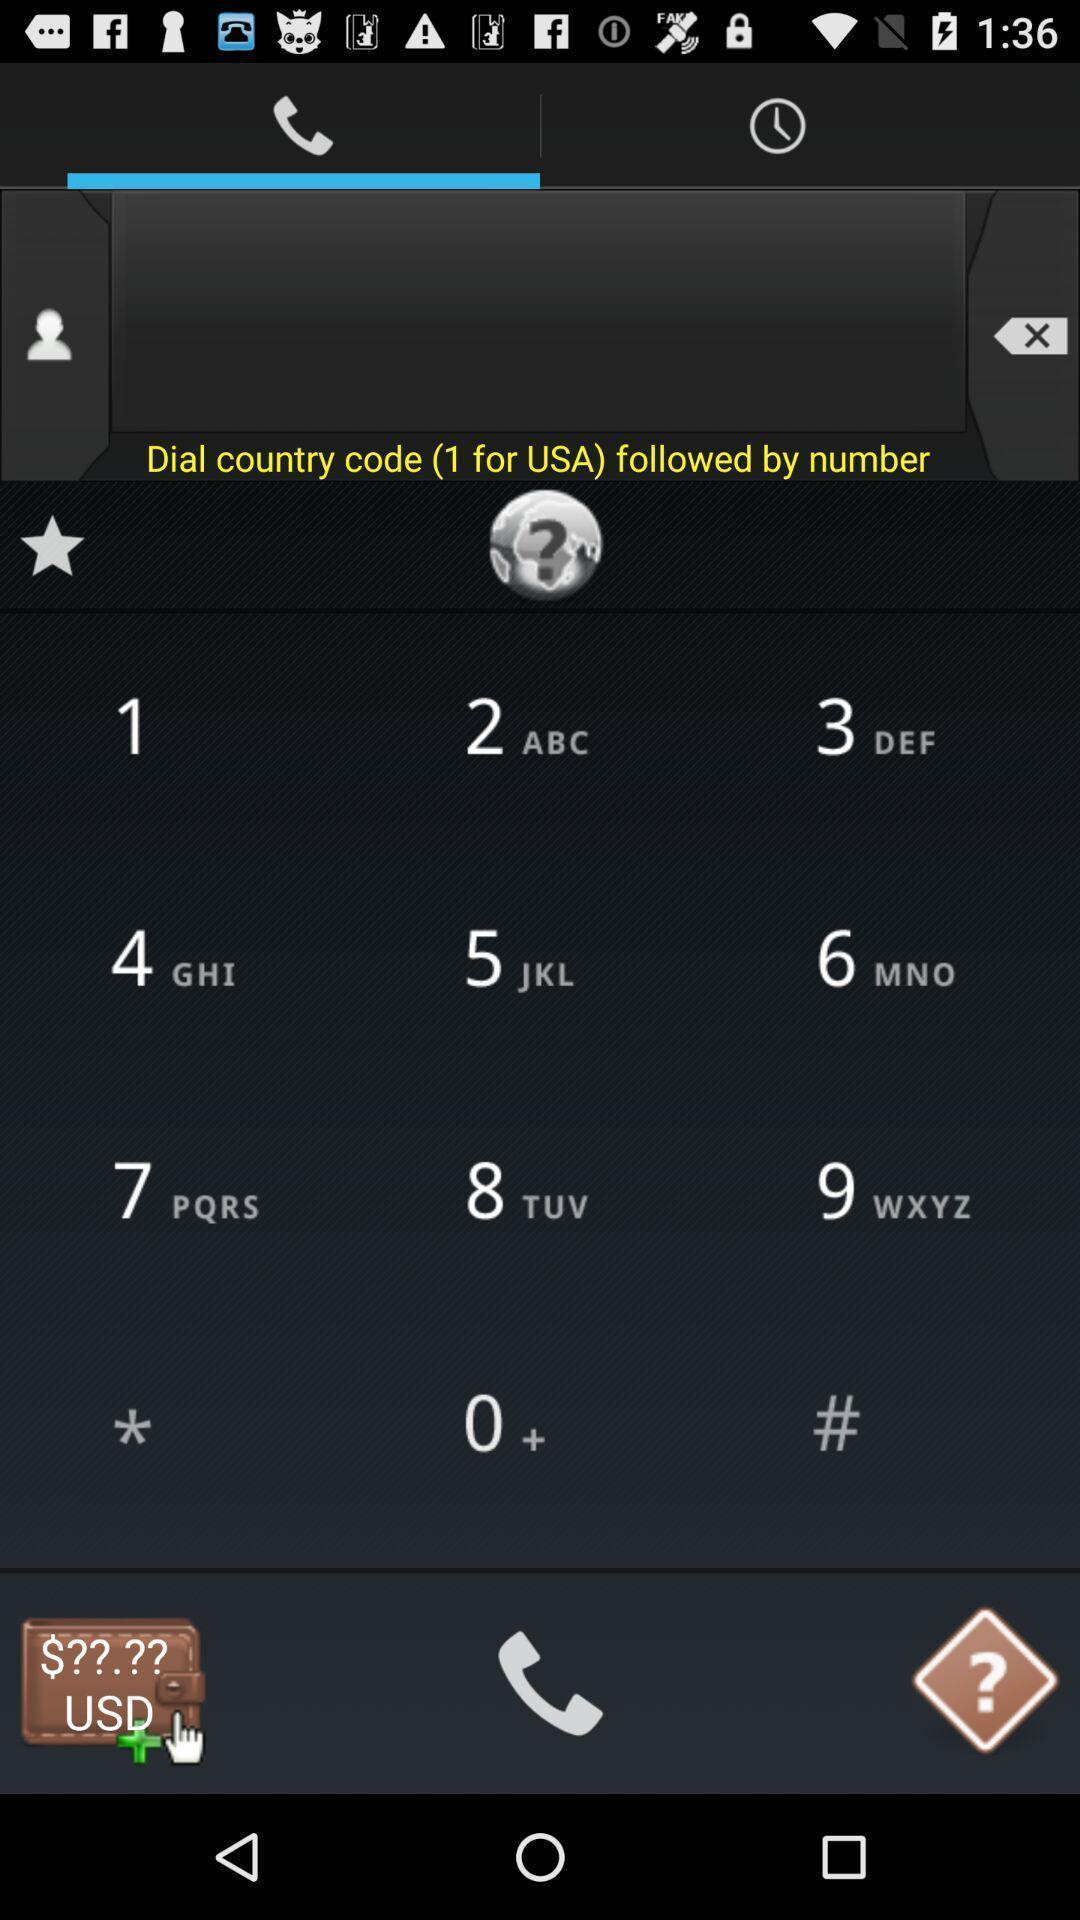What is the overall content of this screenshot? Screen displaying dial pad with options. 